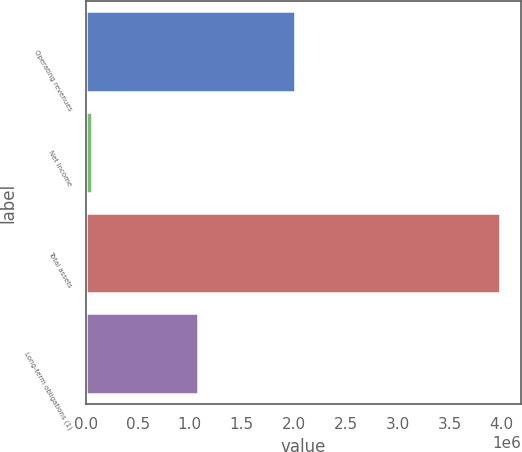<chart> <loc_0><loc_0><loc_500><loc_500><bar_chart><fcel>Operating revenues<fcel>Net Income<fcel>Total assets<fcel>Long-term obligations (1)<nl><fcel>2.01226e+06<fcel>57895<fcel>3.98477e+06<fcel>1.08437e+06<nl></chart> 